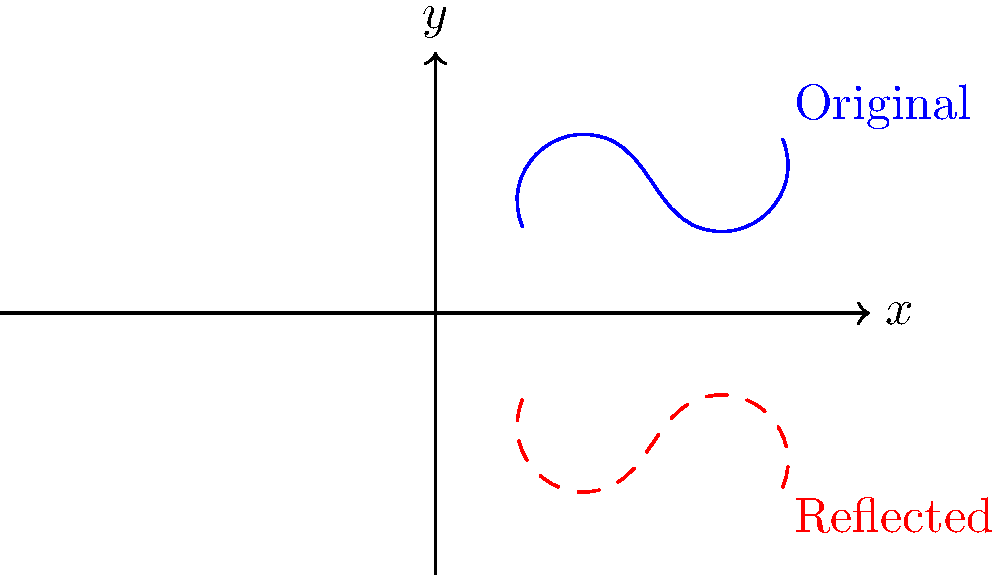A DNA strand is represented by the blue curve in the coordinate plane. If this strand is reflected across the x-axis, which of the following statements is true about the resulting reflected strand (shown in red)?

A) It will have the same base pair sequence as the original strand.
B) It will have a complementary base pair sequence to the original strand.
C) It will have a reversed base pair sequence compared to the original strand.
D) It will have both a reversed and complementary base pair sequence to the original strand. Let's approach this step-by-step:

1) First, recall that DNA strands have a directionality (5' to 3' end).

2) Reflection across the x-axis involves changing the sign of the y-coordinate for each point while keeping the x-coordinate the same. This operation does not change the left-to-right order of the bases.

3) However, reflection does invert the strand vertically. In molecular biology terms, this is equivalent to flipping the strand "upside down."

4) When a DNA strand is flipped upside down:
   - The 5' end becomes the 3' end, and vice versa.
   - The sequence of bases is reversed.

5) Additionally, in a real biological context, DNA strands are always read in the 5' to 3' direction.

6) Therefore, when we read the reflected strand from left to right (which would be from its new 5' end to its new 3' end), we would be reading the original sequence in reverse order.

7) It's important to note that this reflection does not change the identity of the bases themselves. A-T and C-G pairings remain the same; we're only changing the order in which they appear.

8) This operation does not create a complementary strand (which would involve replacing A with T, T with A, C with G, and G with C).
Answer: C) It will have a reversed base pair sequence compared to the original strand. 